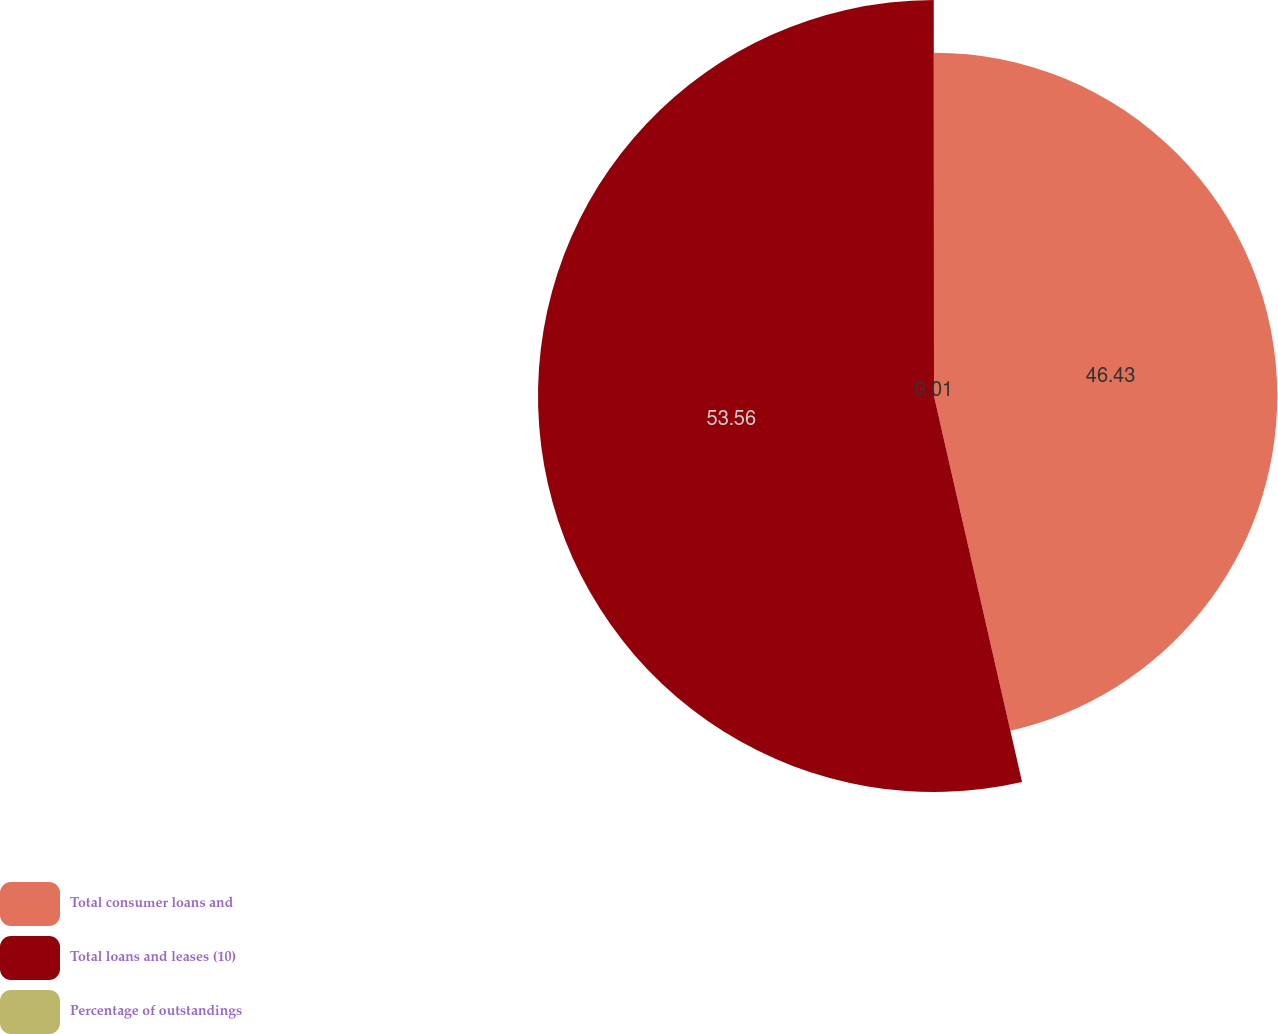Convert chart to OTSL. <chart><loc_0><loc_0><loc_500><loc_500><pie_chart><fcel>Total consumer loans and<fcel>Total loans and leases (10)<fcel>Percentage of outstandings<nl><fcel>46.43%<fcel>53.56%<fcel>0.01%<nl></chart> 